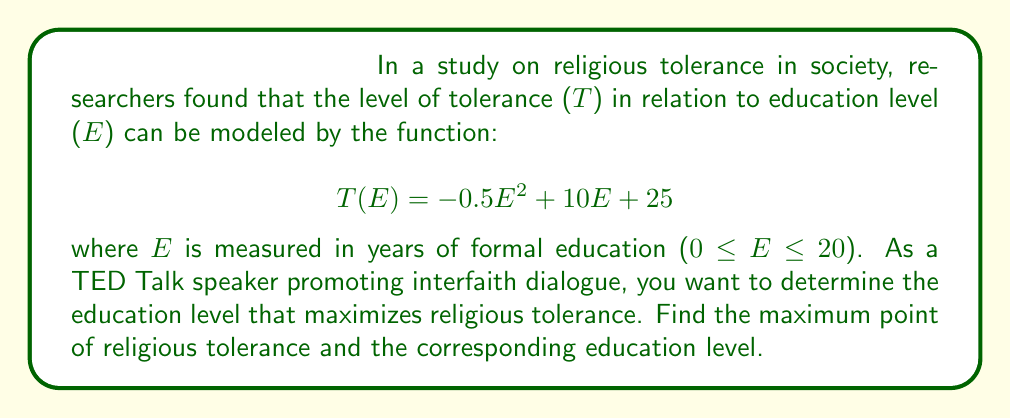What is the answer to this math problem? To find the maximum point of religious tolerance, we need to find the critical point of the function T(E) and determine if it's a maximum.

Step 1: Find the derivative of T(E)
$$T'(E) = \frac{d}{dE}(-0.5E^2 + 10E + 25)$$
$$T'(E) = -E + 10$$

Step 2: Set the derivative equal to zero and solve for E
$$T'(E) = 0$$
$$-E + 10 = 0$$
$$E = 10$$

Step 3: Verify that this critical point is a maximum
To confirm this is a maximum, we can check the second derivative:
$$T''(E) = \frac{d}{dE}(-E + 10) = -1$$

Since T''(E) is negative, the critical point E = 10 is indeed a maximum.

Step 4: Calculate the maximum tolerance level
$$T(10) = -0.5(10)^2 + 10(10) + 25$$
$$T(10) = -50 + 100 + 25 = 75$$

Therefore, the maximum point of religious tolerance occurs when E = 10 years of education, and the corresponding tolerance level is T(10) = 75.
Answer: Maximum tolerance at E = 10 years, T(10) = 75 